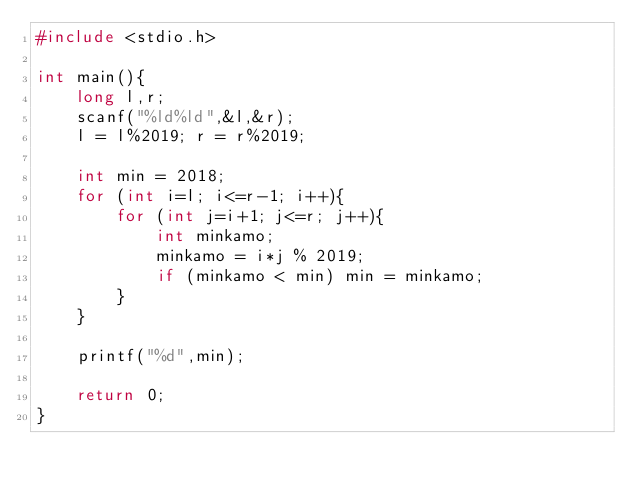Convert code to text. <code><loc_0><loc_0><loc_500><loc_500><_C_>#include <stdio.h>

int main(){
	long l,r;
	scanf("%ld%ld",&l,&r);
	l = l%2019; r = r%2019;
	
	int min = 2018;
	for (int i=l; i<=r-1; i++){
		for (int j=i+1; j<=r; j++){
			int minkamo;
            minkamo = i*j % 2019;
			if (minkamo < min) min = minkamo;
		}
	}
	
	printf("%d",min);
  
    return 0;
}
</code> 